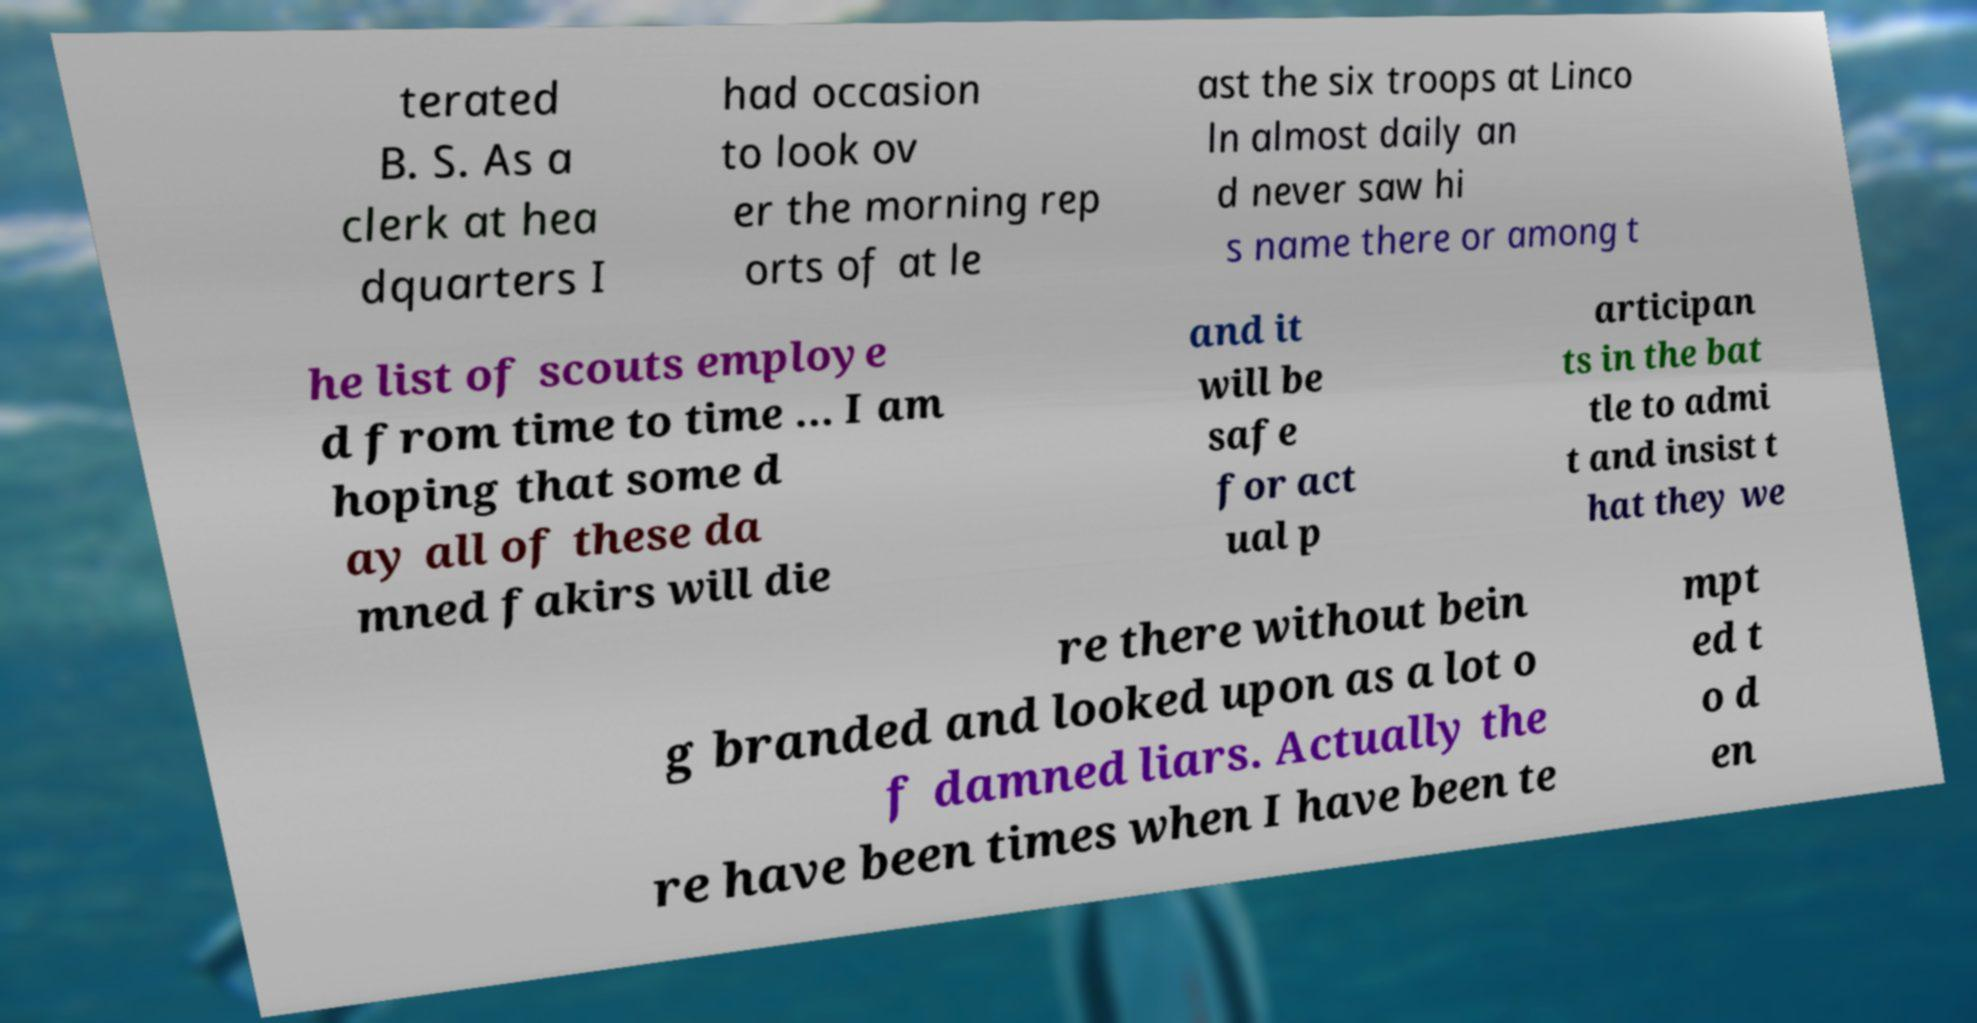Please read and relay the text visible in this image. What does it say? terated B. S. As a clerk at hea dquarters I had occasion to look ov er the morning rep orts of at le ast the six troops at Linco ln almost daily an d never saw hi s name there or among t he list of scouts employe d from time to time ... I am hoping that some d ay all of these da mned fakirs will die and it will be safe for act ual p articipan ts in the bat tle to admi t and insist t hat they we re there without bein g branded and looked upon as a lot o f damned liars. Actually the re have been times when I have been te mpt ed t o d en 